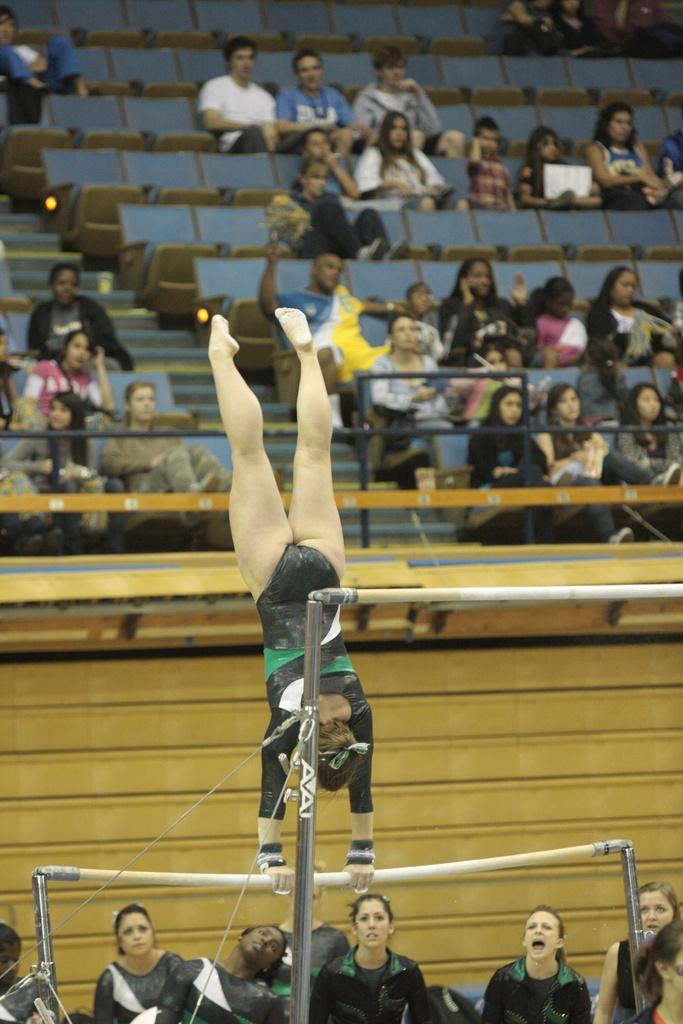<image>
Write a terse but informative summary of the picture. The letters AA are visible on a vaulting pole. 